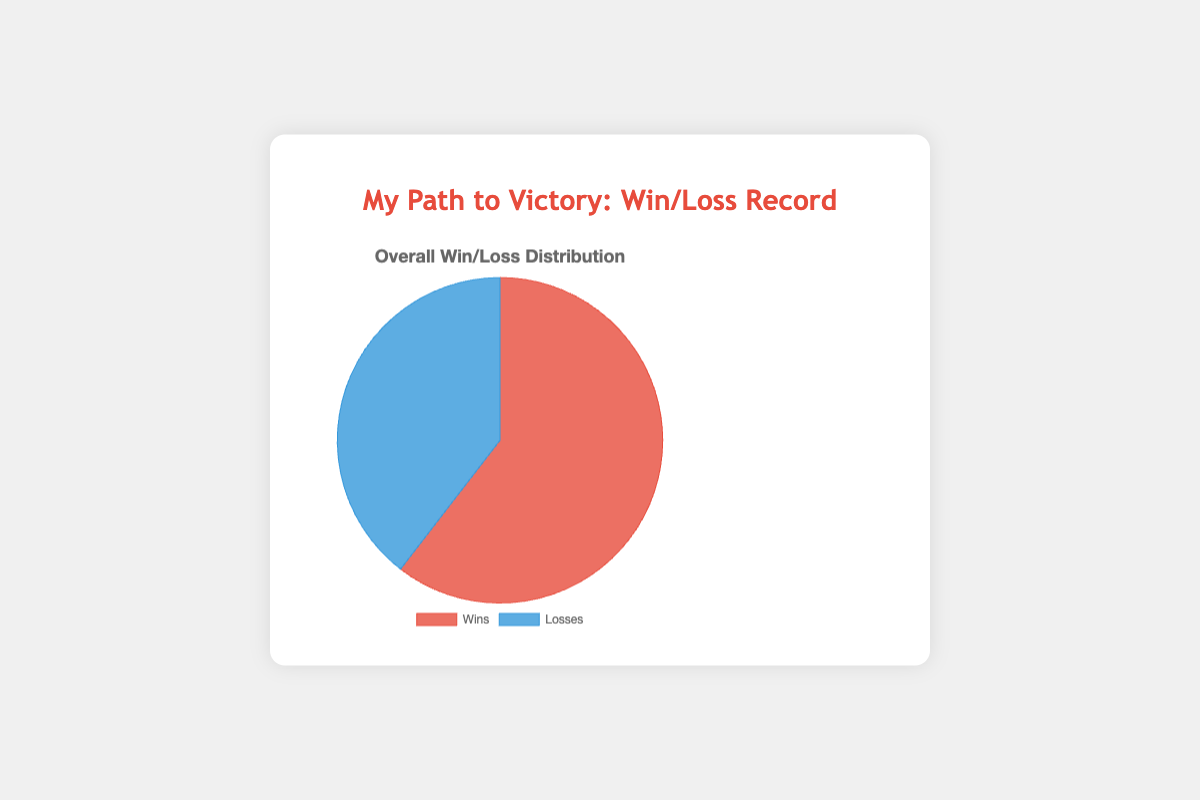What is the total number of wins? To find the total number of wins, sum the win counts for all opponents: 3+5+2+4+6+1+3+2 = 26
Answer: 26 What is the total number of losses? To find the total number of losses, sum the loss counts for all opponents: 2+1+3+2+0+4+3+2 = 17
Answer: 17 What is the win percentage? To find the win percentage, divide the total number of wins by the total number of matches (wins + losses) and multiply by 100: (26 / (26 + 17)) * 100 ≈ 60.47%
Answer: 60.47% Which outcome (win or loss) has the larger count? From the pie chart data, the total wins (26) and losses (17) are given. Since 26 is greater than 17, wins have the larger count.
Answer: Wins How many more wins are there compared to losses? Subtract the total number of losses from the total number of wins: 26 - 17 = 9
Answer: 9 What is the ratio of wins to losses? To find the ratio, divide the total wins by the total losses: 26 / 17 ≈ 1.53
Answer: 1.53 How much greater is the win percentage compared to the loss percentage? Calculate the loss percentage as 100% - win percentage: 100% - 60.47% = 39.53%, then subtract the loss percentage from the win percentage: 60.47% - 39.53% = 20.94%
Answer: 20.94% Among the matches, what is the highest number of wins against a single opponent and who is the opponent? The highest number of wins is 6 (Morgan Brown).
Answer: 6 (Morgan Brown) Which opponent has the highest number of losses? Taylor White has the highest number of losses with 4.
Answer: Taylor White Compared to John Doe, how many more matches did I win against Morgan Brown? Wins against John Doe: 3. Wins against Morgan Brown: 6. Subtract the wins against John Doe from those against Morgan Brown: 6 - 3 = 3
Answer: 3 